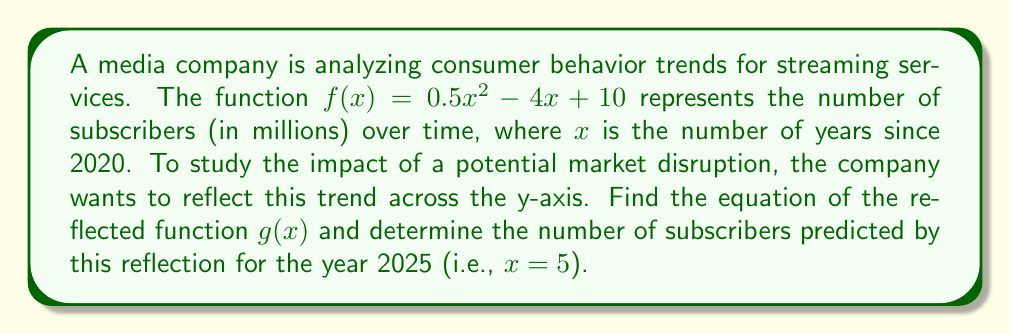Can you answer this question? To solve this problem, we'll follow these steps:

1) To reflect a function across the y-axis, we replace every $x$ with $-x$. So, $g(x) = f(-x)$.

2) Starting with $f(x) = 0.5x^2 - 4x + 10$, we substitute $-x$ for $x$:

   $g(x) = 0.5(-x)^2 - 4(-x) + 10$

3) Simplify:
   $g(x) = 0.5x^2 + 4x + 10$

   Note that the $x^2$ term remains unchanged because $(-x)^2 = x^2$, while the linear term changes sign.

4) To find the number of subscribers in 2025, we need to evaluate $g(5)$:

   $g(5) = 0.5(5)^2 + 4(5) + 10$
   $= 0.5(25) + 20 + 10$
   $= 12.5 + 20 + 10$
   $= 42.5$

This reflection essentially models a scenario where the trend of subscriber growth is reversed, which could represent a market where early adoption was high but growth slows over time - a pattern that might be used to argue against stricter regulations that could stifle innovation in the streaming industry.
Answer: The equation of the reflected function is $g(x) = 0.5x^2 + 4x + 10$, and the predicted number of subscribers in 2025 is 42.5 million. 